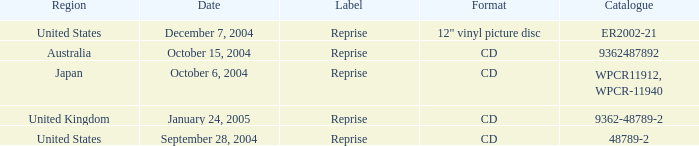Can you identify the australian catalogue? 9362487892.0. Would you mind parsing the complete table? {'header': ['Region', 'Date', 'Label', 'Format', 'Catalogue'], 'rows': [['United States', 'December 7, 2004', 'Reprise', '12" vinyl picture disc', 'ER2002-21'], ['Australia', 'October 15, 2004', 'Reprise', 'CD', '9362487892'], ['Japan', 'October 6, 2004', 'Reprise', 'CD', 'WPCR11912, WPCR-11940'], ['United Kingdom', 'January 24, 2005', 'Reprise', 'CD', '9362-48789-2'], ['United States', 'September 28, 2004', 'Reprise', 'CD', '48789-2']]} 